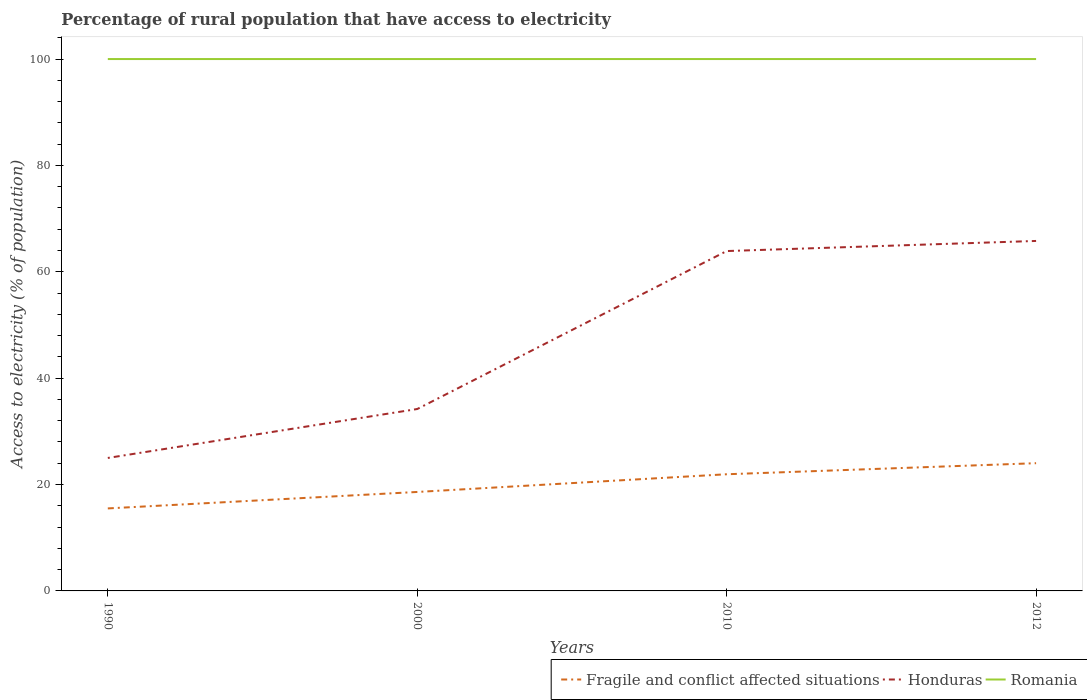Does the line corresponding to Honduras intersect with the line corresponding to Fragile and conflict affected situations?
Your response must be concise. No. Across all years, what is the maximum percentage of rural population that have access to electricity in Fragile and conflict affected situations?
Ensure brevity in your answer.  15.51. What is the total percentage of rural population that have access to electricity in Honduras in the graph?
Make the answer very short. -40.8. What is the difference between the highest and the second highest percentage of rural population that have access to electricity in Honduras?
Ensure brevity in your answer.  40.8. Is the percentage of rural population that have access to electricity in Fragile and conflict affected situations strictly greater than the percentage of rural population that have access to electricity in Romania over the years?
Make the answer very short. Yes. How many years are there in the graph?
Give a very brief answer. 4. What is the difference between two consecutive major ticks on the Y-axis?
Ensure brevity in your answer.  20. Are the values on the major ticks of Y-axis written in scientific E-notation?
Offer a very short reply. No. Does the graph contain grids?
Your answer should be very brief. No. Where does the legend appear in the graph?
Make the answer very short. Bottom right. How many legend labels are there?
Offer a terse response. 3. How are the legend labels stacked?
Offer a terse response. Horizontal. What is the title of the graph?
Your answer should be compact. Percentage of rural population that have access to electricity. Does "Oman" appear as one of the legend labels in the graph?
Make the answer very short. No. What is the label or title of the X-axis?
Make the answer very short. Years. What is the label or title of the Y-axis?
Provide a succinct answer. Access to electricity (% of population). What is the Access to electricity (% of population) in Fragile and conflict affected situations in 1990?
Provide a short and direct response. 15.51. What is the Access to electricity (% of population) of Fragile and conflict affected situations in 2000?
Ensure brevity in your answer.  18.61. What is the Access to electricity (% of population) in Honduras in 2000?
Offer a very short reply. 34.2. What is the Access to electricity (% of population) in Romania in 2000?
Ensure brevity in your answer.  100. What is the Access to electricity (% of population) in Fragile and conflict affected situations in 2010?
Ensure brevity in your answer.  21.94. What is the Access to electricity (% of population) of Honduras in 2010?
Provide a short and direct response. 63.9. What is the Access to electricity (% of population) of Romania in 2010?
Ensure brevity in your answer.  100. What is the Access to electricity (% of population) of Fragile and conflict affected situations in 2012?
Give a very brief answer. 24.01. What is the Access to electricity (% of population) in Honduras in 2012?
Your answer should be compact. 65.8. Across all years, what is the maximum Access to electricity (% of population) in Fragile and conflict affected situations?
Provide a short and direct response. 24.01. Across all years, what is the maximum Access to electricity (% of population) of Honduras?
Give a very brief answer. 65.8. Across all years, what is the maximum Access to electricity (% of population) in Romania?
Offer a terse response. 100. Across all years, what is the minimum Access to electricity (% of population) of Fragile and conflict affected situations?
Offer a terse response. 15.51. Across all years, what is the minimum Access to electricity (% of population) of Honduras?
Keep it short and to the point. 25. Across all years, what is the minimum Access to electricity (% of population) in Romania?
Your answer should be compact. 100. What is the total Access to electricity (% of population) in Fragile and conflict affected situations in the graph?
Your answer should be compact. 80.07. What is the total Access to electricity (% of population) in Honduras in the graph?
Make the answer very short. 188.9. What is the difference between the Access to electricity (% of population) of Fragile and conflict affected situations in 1990 and that in 2000?
Give a very brief answer. -3.1. What is the difference between the Access to electricity (% of population) of Honduras in 1990 and that in 2000?
Provide a succinct answer. -9.2. What is the difference between the Access to electricity (% of population) in Romania in 1990 and that in 2000?
Provide a short and direct response. 0. What is the difference between the Access to electricity (% of population) in Fragile and conflict affected situations in 1990 and that in 2010?
Give a very brief answer. -6.42. What is the difference between the Access to electricity (% of population) of Honduras in 1990 and that in 2010?
Give a very brief answer. -38.9. What is the difference between the Access to electricity (% of population) in Fragile and conflict affected situations in 1990 and that in 2012?
Ensure brevity in your answer.  -8.5. What is the difference between the Access to electricity (% of population) in Honduras in 1990 and that in 2012?
Your answer should be very brief. -40.8. What is the difference between the Access to electricity (% of population) of Romania in 1990 and that in 2012?
Provide a succinct answer. 0. What is the difference between the Access to electricity (% of population) of Fragile and conflict affected situations in 2000 and that in 2010?
Make the answer very short. -3.33. What is the difference between the Access to electricity (% of population) in Honduras in 2000 and that in 2010?
Make the answer very short. -29.7. What is the difference between the Access to electricity (% of population) in Fragile and conflict affected situations in 2000 and that in 2012?
Your answer should be very brief. -5.41. What is the difference between the Access to electricity (% of population) in Honduras in 2000 and that in 2012?
Give a very brief answer. -31.6. What is the difference between the Access to electricity (% of population) in Fragile and conflict affected situations in 2010 and that in 2012?
Provide a succinct answer. -2.08. What is the difference between the Access to electricity (% of population) in Honduras in 2010 and that in 2012?
Make the answer very short. -1.9. What is the difference between the Access to electricity (% of population) in Romania in 2010 and that in 2012?
Give a very brief answer. 0. What is the difference between the Access to electricity (% of population) of Fragile and conflict affected situations in 1990 and the Access to electricity (% of population) of Honduras in 2000?
Offer a very short reply. -18.69. What is the difference between the Access to electricity (% of population) of Fragile and conflict affected situations in 1990 and the Access to electricity (% of population) of Romania in 2000?
Keep it short and to the point. -84.49. What is the difference between the Access to electricity (% of population) of Honduras in 1990 and the Access to electricity (% of population) of Romania in 2000?
Offer a terse response. -75. What is the difference between the Access to electricity (% of population) of Fragile and conflict affected situations in 1990 and the Access to electricity (% of population) of Honduras in 2010?
Your response must be concise. -48.39. What is the difference between the Access to electricity (% of population) in Fragile and conflict affected situations in 1990 and the Access to electricity (% of population) in Romania in 2010?
Your answer should be very brief. -84.49. What is the difference between the Access to electricity (% of population) in Honduras in 1990 and the Access to electricity (% of population) in Romania in 2010?
Keep it short and to the point. -75. What is the difference between the Access to electricity (% of population) in Fragile and conflict affected situations in 1990 and the Access to electricity (% of population) in Honduras in 2012?
Your answer should be compact. -50.29. What is the difference between the Access to electricity (% of population) in Fragile and conflict affected situations in 1990 and the Access to electricity (% of population) in Romania in 2012?
Give a very brief answer. -84.49. What is the difference between the Access to electricity (% of population) of Honduras in 1990 and the Access to electricity (% of population) of Romania in 2012?
Give a very brief answer. -75. What is the difference between the Access to electricity (% of population) of Fragile and conflict affected situations in 2000 and the Access to electricity (% of population) of Honduras in 2010?
Your answer should be compact. -45.29. What is the difference between the Access to electricity (% of population) in Fragile and conflict affected situations in 2000 and the Access to electricity (% of population) in Romania in 2010?
Keep it short and to the point. -81.39. What is the difference between the Access to electricity (% of population) in Honduras in 2000 and the Access to electricity (% of population) in Romania in 2010?
Your answer should be very brief. -65.8. What is the difference between the Access to electricity (% of population) of Fragile and conflict affected situations in 2000 and the Access to electricity (% of population) of Honduras in 2012?
Offer a terse response. -47.19. What is the difference between the Access to electricity (% of population) in Fragile and conflict affected situations in 2000 and the Access to electricity (% of population) in Romania in 2012?
Provide a succinct answer. -81.39. What is the difference between the Access to electricity (% of population) in Honduras in 2000 and the Access to electricity (% of population) in Romania in 2012?
Provide a succinct answer. -65.8. What is the difference between the Access to electricity (% of population) of Fragile and conflict affected situations in 2010 and the Access to electricity (% of population) of Honduras in 2012?
Your answer should be very brief. -43.86. What is the difference between the Access to electricity (% of population) of Fragile and conflict affected situations in 2010 and the Access to electricity (% of population) of Romania in 2012?
Your answer should be very brief. -78.06. What is the difference between the Access to electricity (% of population) in Honduras in 2010 and the Access to electricity (% of population) in Romania in 2012?
Your response must be concise. -36.1. What is the average Access to electricity (% of population) in Fragile and conflict affected situations per year?
Give a very brief answer. 20.02. What is the average Access to electricity (% of population) of Honduras per year?
Keep it short and to the point. 47.23. What is the average Access to electricity (% of population) in Romania per year?
Make the answer very short. 100. In the year 1990, what is the difference between the Access to electricity (% of population) in Fragile and conflict affected situations and Access to electricity (% of population) in Honduras?
Your answer should be compact. -9.49. In the year 1990, what is the difference between the Access to electricity (% of population) in Fragile and conflict affected situations and Access to electricity (% of population) in Romania?
Your answer should be very brief. -84.49. In the year 1990, what is the difference between the Access to electricity (% of population) in Honduras and Access to electricity (% of population) in Romania?
Ensure brevity in your answer.  -75. In the year 2000, what is the difference between the Access to electricity (% of population) in Fragile and conflict affected situations and Access to electricity (% of population) in Honduras?
Offer a terse response. -15.59. In the year 2000, what is the difference between the Access to electricity (% of population) in Fragile and conflict affected situations and Access to electricity (% of population) in Romania?
Keep it short and to the point. -81.39. In the year 2000, what is the difference between the Access to electricity (% of population) in Honduras and Access to electricity (% of population) in Romania?
Make the answer very short. -65.8. In the year 2010, what is the difference between the Access to electricity (% of population) in Fragile and conflict affected situations and Access to electricity (% of population) in Honduras?
Offer a terse response. -41.96. In the year 2010, what is the difference between the Access to electricity (% of population) in Fragile and conflict affected situations and Access to electricity (% of population) in Romania?
Your answer should be very brief. -78.06. In the year 2010, what is the difference between the Access to electricity (% of population) in Honduras and Access to electricity (% of population) in Romania?
Keep it short and to the point. -36.1. In the year 2012, what is the difference between the Access to electricity (% of population) in Fragile and conflict affected situations and Access to electricity (% of population) in Honduras?
Your answer should be very brief. -41.79. In the year 2012, what is the difference between the Access to electricity (% of population) of Fragile and conflict affected situations and Access to electricity (% of population) of Romania?
Give a very brief answer. -75.99. In the year 2012, what is the difference between the Access to electricity (% of population) in Honduras and Access to electricity (% of population) in Romania?
Your response must be concise. -34.2. What is the ratio of the Access to electricity (% of population) in Fragile and conflict affected situations in 1990 to that in 2000?
Ensure brevity in your answer.  0.83. What is the ratio of the Access to electricity (% of population) of Honduras in 1990 to that in 2000?
Offer a very short reply. 0.73. What is the ratio of the Access to electricity (% of population) in Romania in 1990 to that in 2000?
Make the answer very short. 1. What is the ratio of the Access to electricity (% of population) in Fragile and conflict affected situations in 1990 to that in 2010?
Keep it short and to the point. 0.71. What is the ratio of the Access to electricity (% of population) in Honduras in 1990 to that in 2010?
Provide a short and direct response. 0.39. What is the ratio of the Access to electricity (% of population) in Fragile and conflict affected situations in 1990 to that in 2012?
Keep it short and to the point. 0.65. What is the ratio of the Access to electricity (% of population) of Honduras in 1990 to that in 2012?
Provide a short and direct response. 0.38. What is the ratio of the Access to electricity (% of population) in Romania in 1990 to that in 2012?
Your answer should be compact. 1. What is the ratio of the Access to electricity (% of population) in Fragile and conflict affected situations in 2000 to that in 2010?
Provide a short and direct response. 0.85. What is the ratio of the Access to electricity (% of population) of Honduras in 2000 to that in 2010?
Make the answer very short. 0.54. What is the ratio of the Access to electricity (% of population) in Fragile and conflict affected situations in 2000 to that in 2012?
Keep it short and to the point. 0.77. What is the ratio of the Access to electricity (% of population) of Honduras in 2000 to that in 2012?
Make the answer very short. 0.52. What is the ratio of the Access to electricity (% of population) in Fragile and conflict affected situations in 2010 to that in 2012?
Provide a short and direct response. 0.91. What is the ratio of the Access to electricity (% of population) of Honduras in 2010 to that in 2012?
Ensure brevity in your answer.  0.97. What is the difference between the highest and the second highest Access to electricity (% of population) of Fragile and conflict affected situations?
Keep it short and to the point. 2.08. What is the difference between the highest and the second highest Access to electricity (% of population) of Honduras?
Ensure brevity in your answer.  1.9. What is the difference between the highest and the second highest Access to electricity (% of population) of Romania?
Provide a succinct answer. 0. What is the difference between the highest and the lowest Access to electricity (% of population) in Fragile and conflict affected situations?
Provide a short and direct response. 8.5. What is the difference between the highest and the lowest Access to electricity (% of population) of Honduras?
Your answer should be compact. 40.8. 